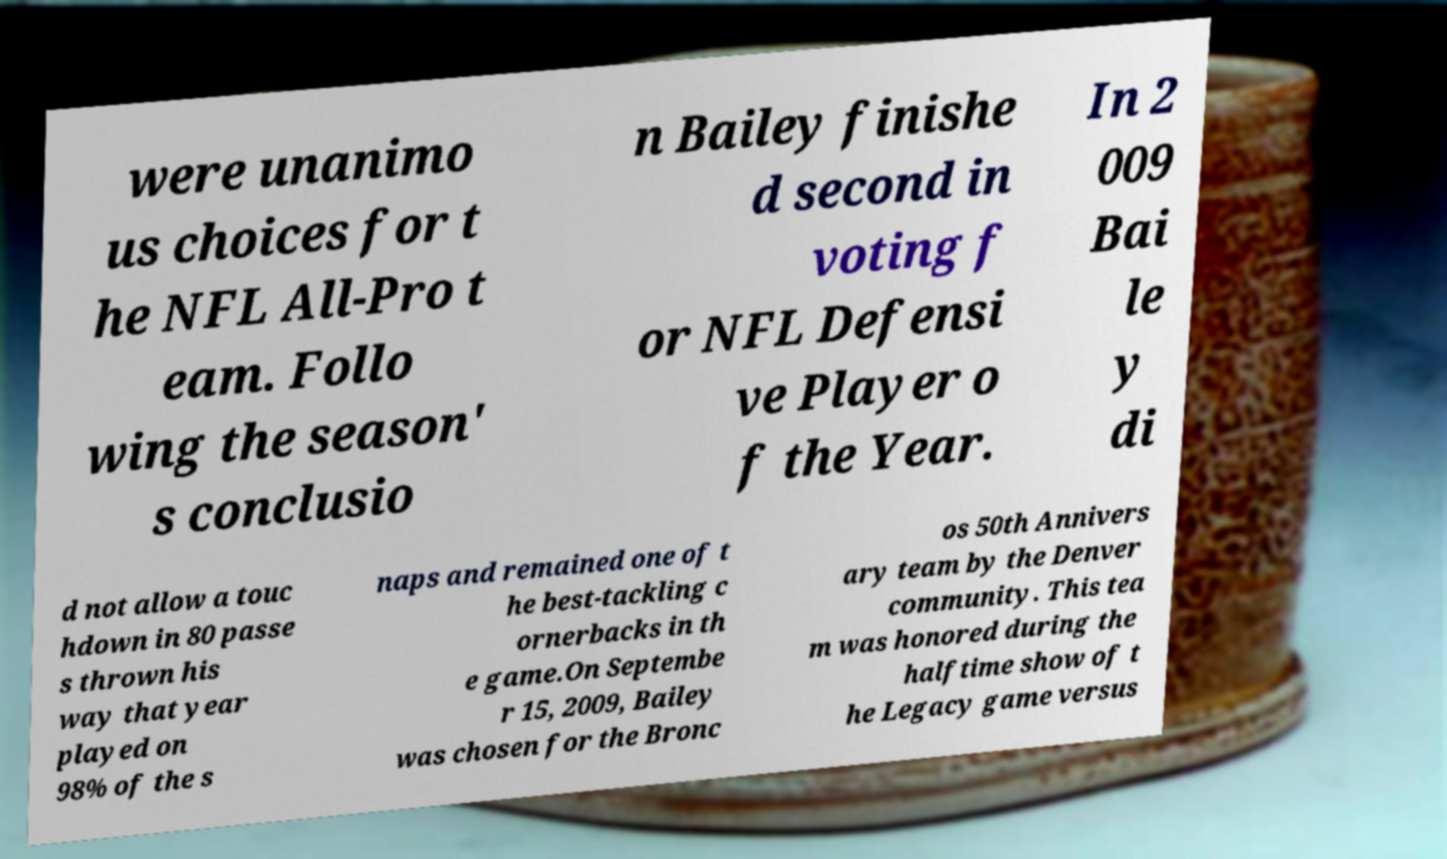What messages or text are displayed in this image? I need them in a readable, typed format. were unanimo us choices for t he NFL All-Pro t eam. Follo wing the season' s conclusio n Bailey finishe d second in voting f or NFL Defensi ve Player o f the Year. In 2 009 Bai le y di d not allow a touc hdown in 80 passe s thrown his way that year played on 98% of the s naps and remained one of t he best-tackling c ornerbacks in th e game.On Septembe r 15, 2009, Bailey was chosen for the Bronc os 50th Annivers ary team by the Denver community. This tea m was honored during the halftime show of t he Legacy game versus 